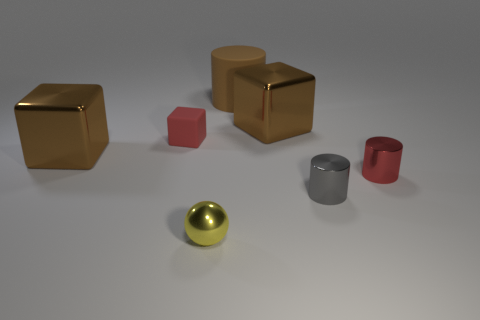The large thing behind the big brown cube right of the large shiny object on the left side of the red cube is what color?
Offer a terse response. Brown. What number of other tiny rubber things have the same shape as the red rubber thing?
Ensure brevity in your answer.  0. What size is the red object that is on the right side of the tiny rubber block that is in front of the large brown rubber thing?
Give a very brief answer. Small. Does the yellow thing have the same size as the gray shiny cylinder?
Give a very brief answer. Yes. There is a brown rubber thing that is left of the small gray thing in front of the brown rubber object; are there any yellow metallic objects that are behind it?
Your response must be concise. No. What size is the brown matte object?
Ensure brevity in your answer.  Large. What number of gray shiny cylinders are the same size as the matte cylinder?
Provide a succinct answer. 0. There is another tiny object that is the same shape as the gray object; what is it made of?
Offer a terse response. Metal. The big object that is both right of the small yellow thing and in front of the brown matte cylinder has what shape?
Provide a succinct answer. Cube. There is a big metal object that is left of the yellow metal sphere; what shape is it?
Provide a short and direct response. Cube. 